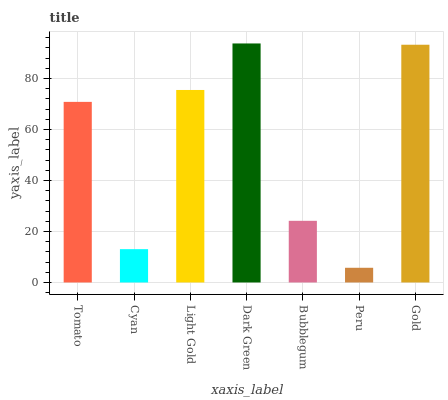Is Peru the minimum?
Answer yes or no. Yes. Is Dark Green the maximum?
Answer yes or no. Yes. Is Cyan the minimum?
Answer yes or no. No. Is Cyan the maximum?
Answer yes or no. No. Is Tomato greater than Cyan?
Answer yes or no. Yes. Is Cyan less than Tomato?
Answer yes or no. Yes. Is Cyan greater than Tomato?
Answer yes or no. No. Is Tomato less than Cyan?
Answer yes or no. No. Is Tomato the high median?
Answer yes or no. Yes. Is Tomato the low median?
Answer yes or no. Yes. Is Bubblegum the high median?
Answer yes or no. No. Is Peru the low median?
Answer yes or no. No. 